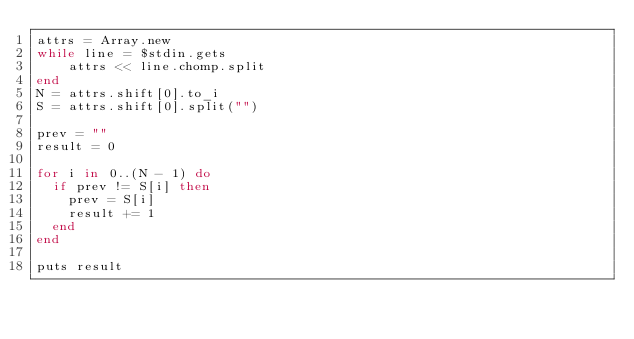Convert code to text. <code><loc_0><loc_0><loc_500><loc_500><_Ruby_>attrs = Array.new
while line = $stdin.gets
    attrs << line.chomp.split
end
N = attrs.shift[0].to_i
S = attrs.shift[0].split("")

prev = ""
result = 0

for i in 0..(N - 1) do
  if prev != S[i] then
    prev = S[i]
    result += 1
  end
end

puts result</code> 